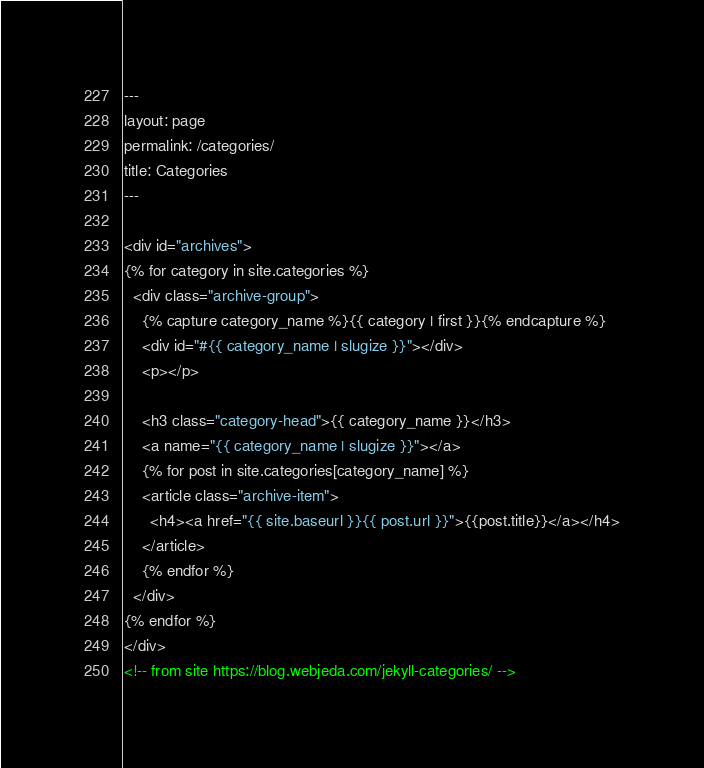Convert code to text. <code><loc_0><loc_0><loc_500><loc_500><_HTML_>---
layout: page
permalink: /categories/
title: Categories
---

<div id="archives">
{% for category in site.categories %}
  <div class="archive-group">
    {% capture category_name %}{{ category | first }}{% endcapture %}
    <div id="#{{ category_name | slugize }}"></div>
    <p></p>

    <h3 class="category-head">{{ category_name }}</h3>
    <a name="{{ category_name | slugize }}"></a>
    {% for post in site.categories[category_name] %}
    <article class="archive-item">
      <h4><a href="{{ site.baseurl }}{{ post.url }}">{{post.title}}</a></h4>
    </article>
    {% endfor %}
  </div>
{% endfor %}
</div>
<!-- from site https://blog.webjeda.com/jekyll-categories/ -->
</code> 